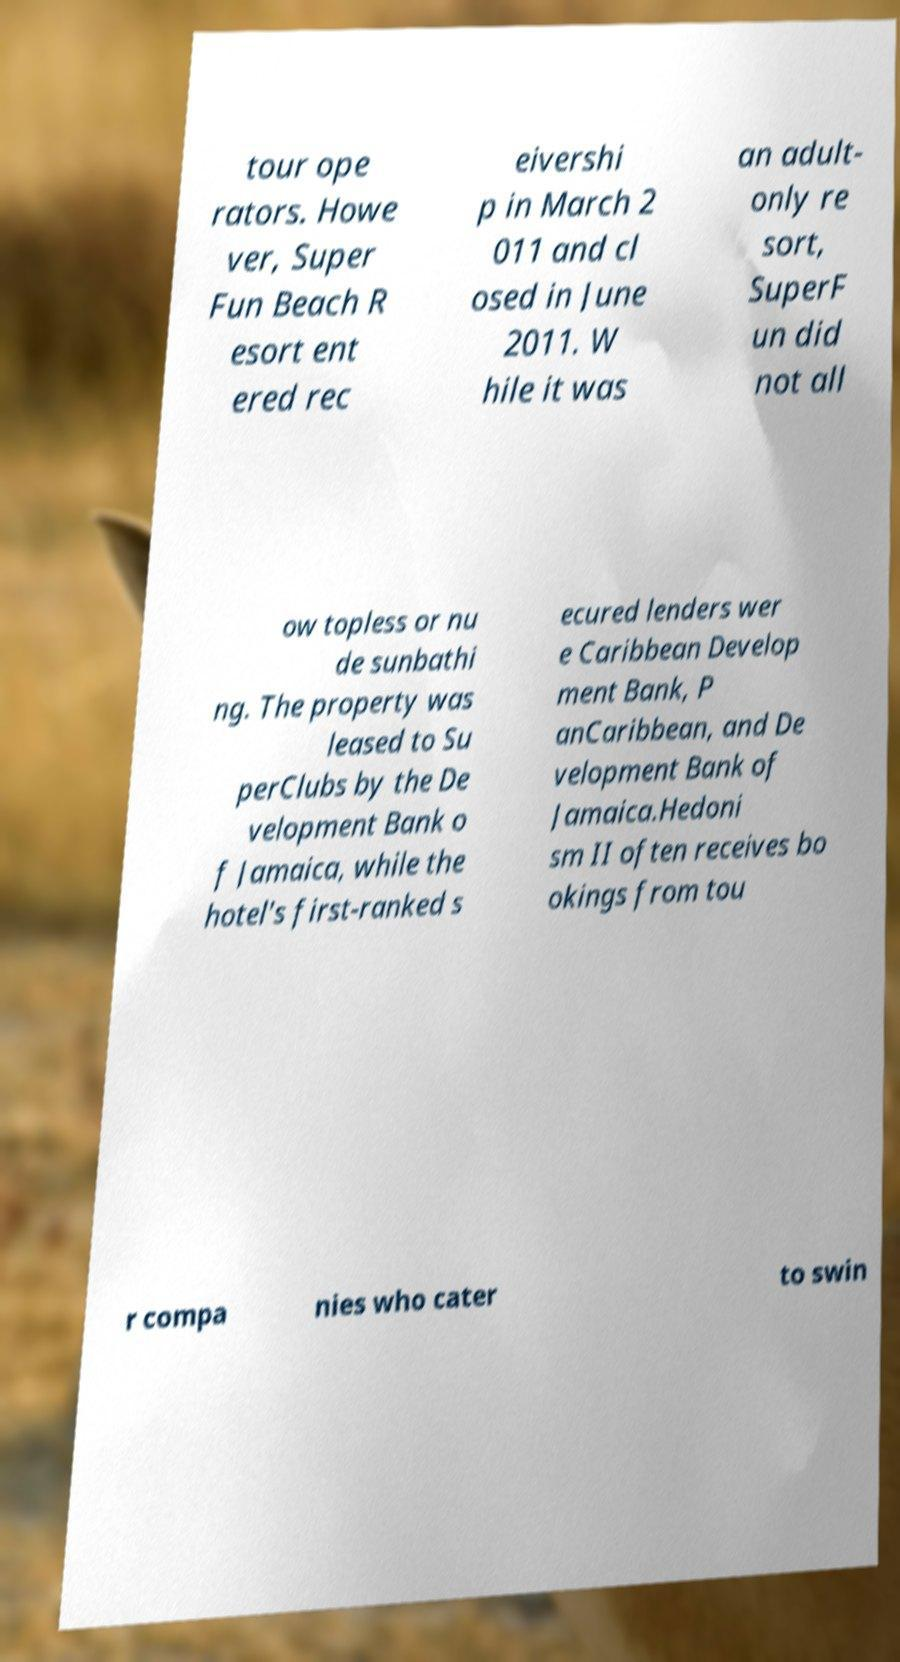Can you accurately transcribe the text from the provided image for me? tour ope rators. Howe ver, Super Fun Beach R esort ent ered rec eivershi p in March 2 011 and cl osed in June 2011. W hile it was an adult- only re sort, SuperF un did not all ow topless or nu de sunbathi ng. The property was leased to Su perClubs by the De velopment Bank o f Jamaica, while the hotel's first-ranked s ecured lenders wer e Caribbean Develop ment Bank, P anCaribbean, and De velopment Bank of Jamaica.Hedoni sm II often receives bo okings from tou r compa nies who cater to swin 